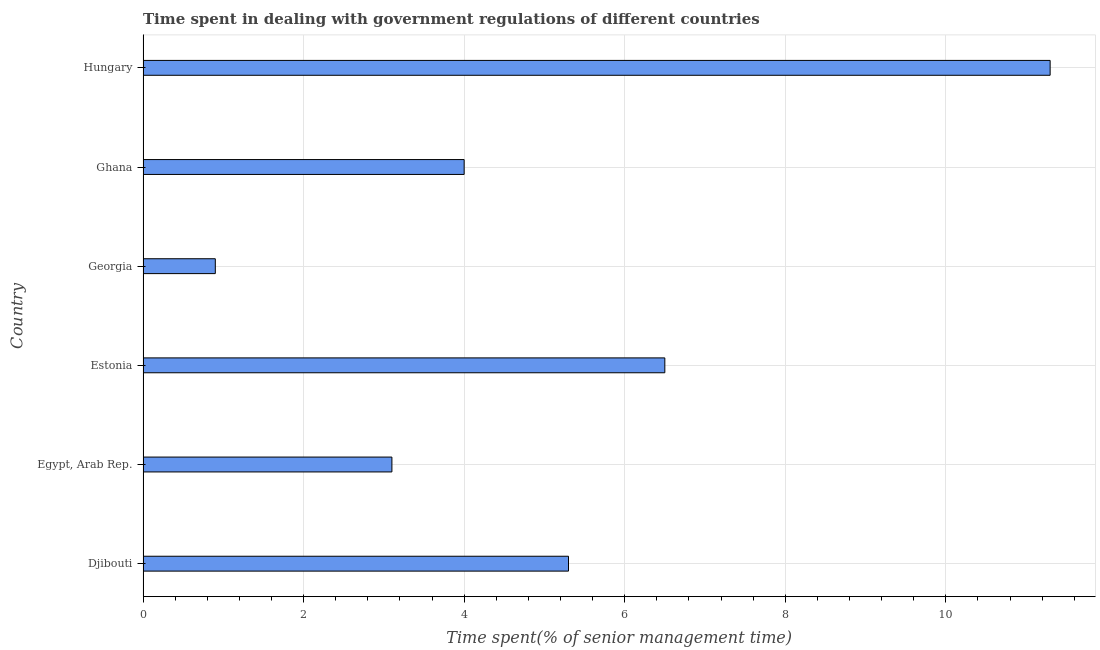Does the graph contain any zero values?
Provide a short and direct response. No. What is the title of the graph?
Keep it short and to the point. Time spent in dealing with government regulations of different countries. What is the label or title of the X-axis?
Make the answer very short. Time spent(% of senior management time). What is the label or title of the Y-axis?
Your answer should be very brief. Country. What is the time spent in dealing with government regulations in Estonia?
Offer a very short reply. 6.5. In which country was the time spent in dealing with government regulations maximum?
Provide a succinct answer. Hungary. In which country was the time spent in dealing with government regulations minimum?
Your answer should be very brief. Georgia. What is the sum of the time spent in dealing with government regulations?
Keep it short and to the point. 31.1. What is the difference between the time spent in dealing with government regulations in Egypt, Arab Rep. and Hungary?
Make the answer very short. -8.2. What is the average time spent in dealing with government regulations per country?
Offer a very short reply. 5.18. What is the median time spent in dealing with government regulations?
Provide a succinct answer. 4.65. In how many countries, is the time spent in dealing with government regulations greater than 0.4 %?
Your response must be concise. 6. What is the ratio of the time spent in dealing with government regulations in Egypt, Arab Rep. to that in Estonia?
Give a very brief answer. 0.48. Is the difference between the time spent in dealing with government regulations in Djibouti and Egypt, Arab Rep. greater than the difference between any two countries?
Ensure brevity in your answer.  No. What is the difference between the highest and the second highest time spent in dealing with government regulations?
Provide a short and direct response. 4.8. In how many countries, is the time spent in dealing with government regulations greater than the average time spent in dealing with government regulations taken over all countries?
Your answer should be very brief. 3. How many bars are there?
Provide a short and direct response. 6. What is the difference between two consecutive major ticks on the X-axis?
Your answer should be very brief. 2. What is the Time spent(% of senior management time) in Egypt, Arab Rep.?
Give a very brief answer. 3.1. What is the Time spent(% of senior management time) of Estonia?
Your answer should be compact. 6.5. What is the Time spent(% of senior management time) in Georgia?
Offer a very short reply. 0.9. What is the Time spent(% of senior management time) of Ghana?
Provide a succinct answer. 4. What is the difference between the Time spent(% of senior management time) in Djibouti and Egypt, Arab Rep.?
Give a very brief answer. 2.2. What is the difference between the Time spent(% of senior management time) in Djibouti and Estonia?
Your answer should be very brief. -1.2. What is the difference between the Time spent(% of senior management time) in Djibouti and Georgia?
Give a very brief answer. 4.4. What is the difference between the Time spent(% of senior management time) in Djibouti and Ghana?
Ensure brevity in your answer.  1.3. What is the difference between the Time spent(% of senior management time) in Djibouti and Hungary?
Your answer should be compact. -6. What is the difference between the Time spent(% of senior management time) in Egypt, Arab Rep. and Estonia?
Make the answer very short. -3.4. What is the difference between the Time spent(% of senior management time) in Estonia and Georgia?
Your response must be concise. 5.6. What is the difference between the Time spent(% of senior management time) in Estonia and Ghana?
Keep it short and to the point. 2.5. What is the ratio of the Time spent(% of senior management time) in Djibouti to that in Egypt, Arab Rep.?
Give a very brief answer. 1.71. What is the ratio of the Time spent(% of senior management time) in Djibouti to that in Estonia?
Provide a short and direct response. 0.81. What is the ratio of the Time spent(% of senior management time) in Djibouti to that in Georgia?
Your response must be concise. 5.89. What is the ratio of the Time spent(% of senior management time) in Djibouti to that in Ghana?
Your response must be concise. 1.32. What is the ratio of the Time spent(% of senior management time) in Djibouti to that in Hungary?
Keep it short and to the point. 0.47. What is the ratio of the Time spent(% of senior management time) in Egypt, Arab Rep. to that in Estonia?
Offer a terse response. 0.48. What is the ratio of the Time spent(% of senior management time) in Egypt, Arab Rep. to that in Georgia?
Offer a very short reply. 3.44. What is the ratio of the Time spent(% of senior management time) in Egypt, Arab Rep. to that in Ghana?
Offer a very short reply. 0.78. What is the ratio of the Time spent(% of senior management time) in Egypt, Arab Rep. to that in Hungary?
Keep it short and to the point. 0.27. What is the ratio of the Time spent(% of senior management time) in Estonia to that in Georgia?
Offer a very short reply. 7.22. What is the ratio of the Time spent(% of senior management time) in Estonia to that in Ghana?
Give a very brief answer. 1.62. What is the ratio of the Time spent(% of senior management time) in Estonia to that in Hungary?
Your response must be concise. 0.57. What is the ratio of the Time spent(% of senior management time) in Georgia to that in Ghana?
Your answer should be compact. 0.23. What is the ratio of the Time spent(% of senior management time) in Georgia to that in Hungary?
Give a very brief answer. 0.08. What is the ratio of the Time spent(% of senior management time) in Ghana to that in Hungary?
Provide a short and direct response. 0.35. 